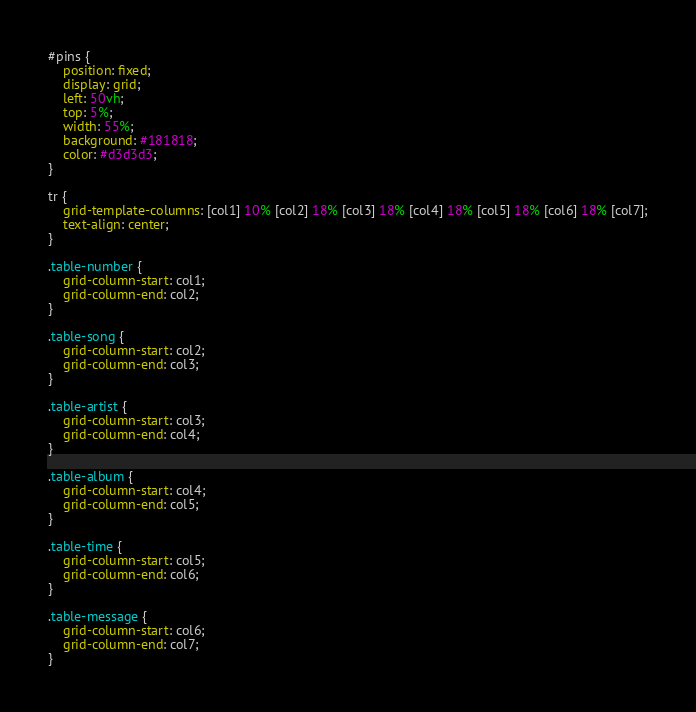Convert code to text. <code><loc_0><loc_0><loc_500><loc_500><_CSS_>#pins {
    position: fixed;
    display: grid;
    left: 50vh;
    top: 5%;
    width: 55%;
    background: #181818;
    color: #d3d3d3;
}

tr {
    grid-template-columns: [col1] 10% [col2] 18% [col3] 18% [col4] 18% [col5] 18% [col6] 18% [col7];
    text-align: center;
}

.table-number {
    grid-column-start: col1;
    grid-column-end: col2;
}

.table-song {
    grid-column-start: col2;
    grid-column-end: col3;
}

.table-artist {
    grid-column-start: col3;
    grid-column-end: col4;
}

.table-album {
    grid-column-start: col4;
    grid-column-end: col5;
}

.table-time {
    grid-column-start: col5;
    grid-column-end: col6;
}

.table-message {
    grid-column-start: col6;
    grid-column-end: col7;
}</code> 